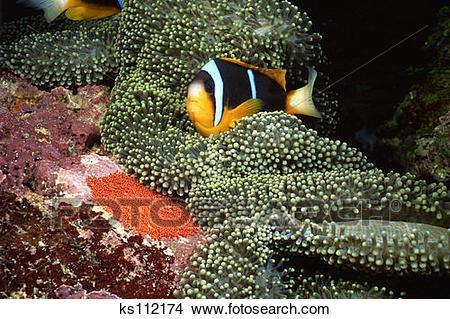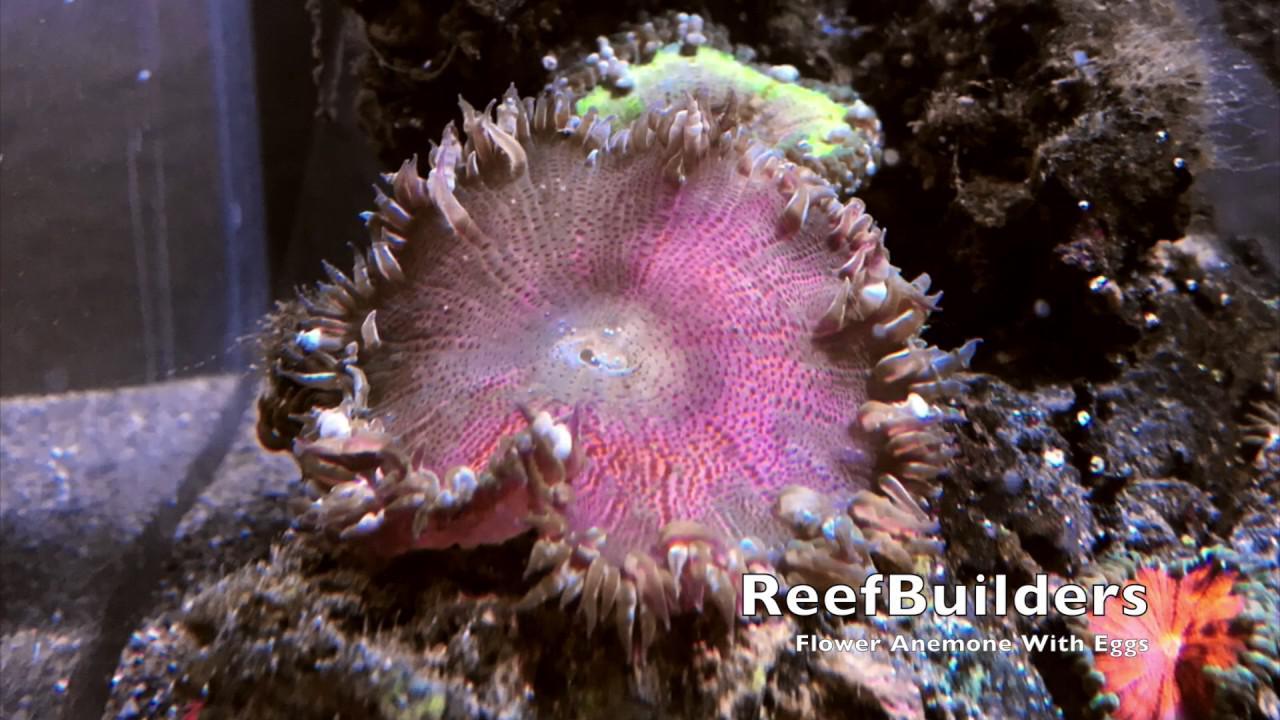The first image is the image on the left, the second image is the image on the right. Examine the images to the left and right. Is the description "In at least one image there is a fish with two white stripes and a black belly swimming through a corral." accurate? Answer yes or no. Yes. 